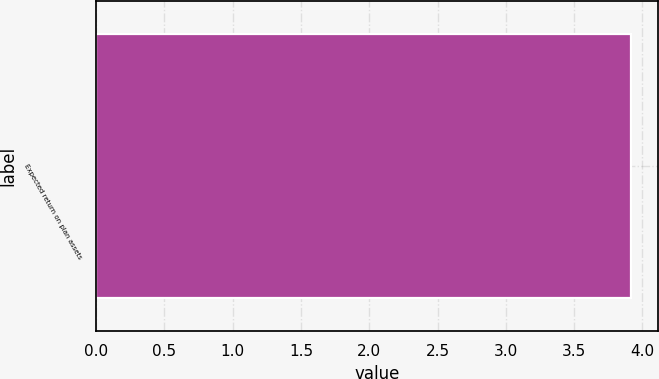Convert chart. <chart><loc_0><loc_0><loc_500><loc_500><bar_chart><fcel>Expected return on plan assets<nl><fcel>3.92<nl></chart> 